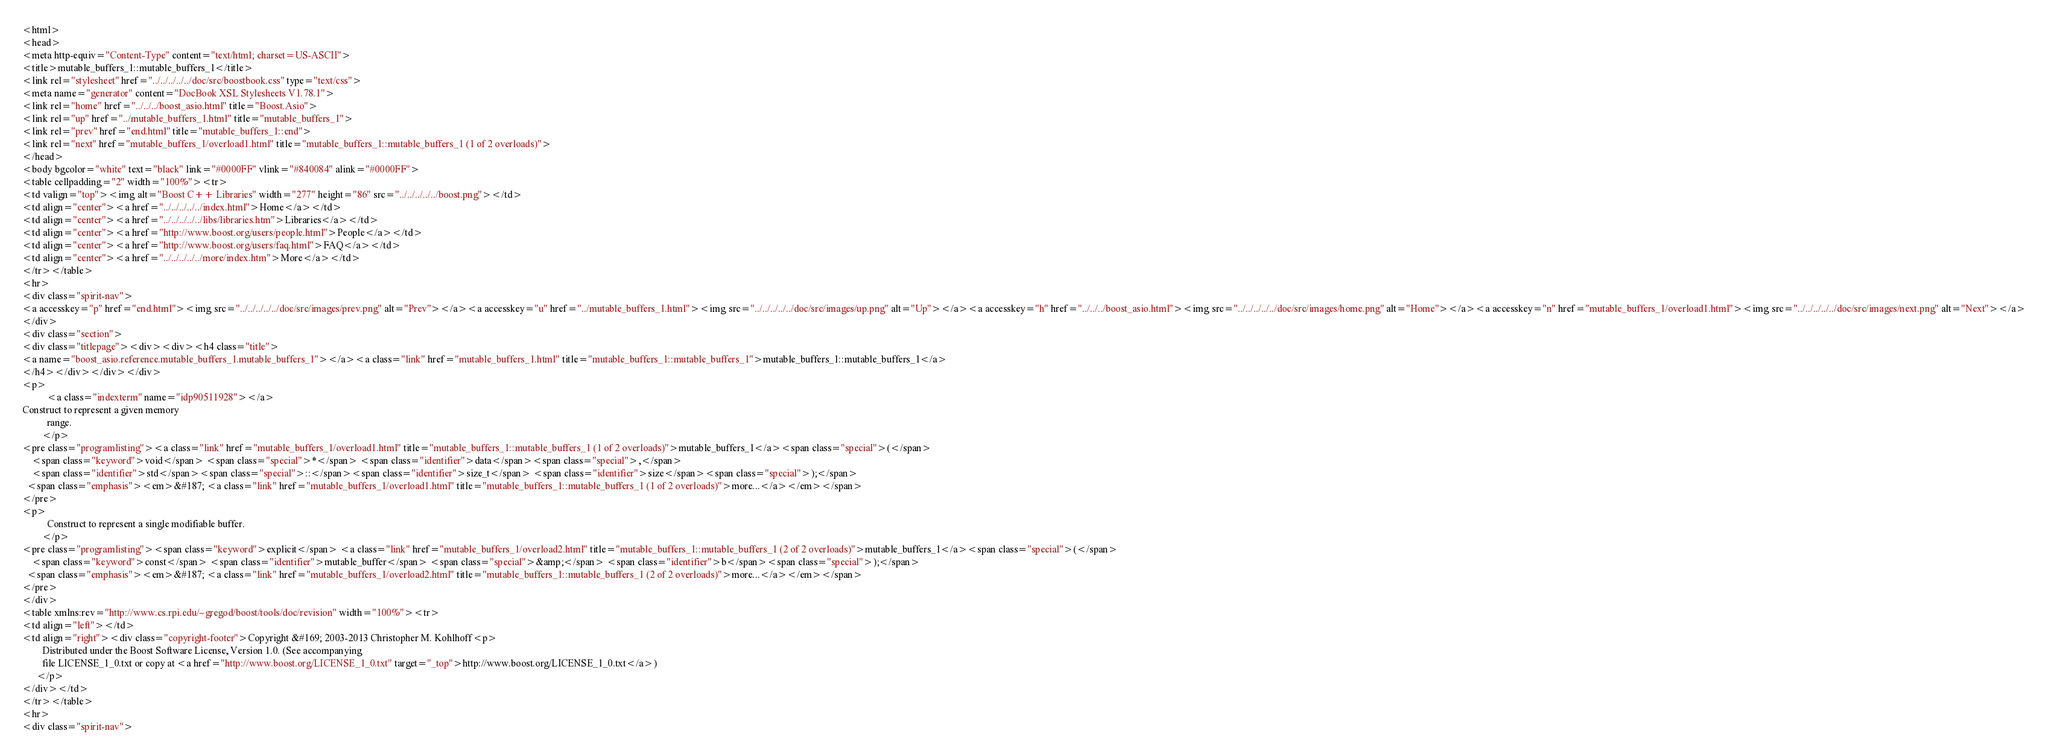<code> <loc_0><loc_0><loc_500><loc_500><_HTML_><html>
<head>
<meta http-equiv="Content-Type" content="text/html; charset=US-ASCII">
<title>mutable_buffers_1::mutable_buffers_1</title>
<link rel="stylesheet" href="../../../../../doc/src/boostbook.css" type="text/css">
<meta name="generator" content="DocBook XSL Stylesheets V1.78.1">
<link rel="home" href="../../../boost_asio.html" title="Boost.Asio">
<link rel="up" href="../mutable_buffers_1.html" title="mutable_buffers_1">
<link rel="prev" href="end.html" title="mutable_buffers_1::end">
<link rel="next" href="mutable_buffers_1/overload1.html" title="mutable_buffers_1::mutable_buffers_1 (1 of 2 overloads)">
</head>
<body bgcolor="white" text="black" link="#0000FF" vlink="#840084" alink="#0000FF">
<table cellpadding="2" width="100%"><tr>
<td valign="top"><img alt="Boost C++ Libraries" width="277" height="86" src="../../../../../boost.png"></td>
<td align="center"><a href="../../../../../index.html">Home</a></td>
<td align="center"><a href="../../../../../libs/libraries.htm">Libraries</a></td>
<td align="center"><a href="http://www.boost.org/users/people.html">People</a></td>
<td align="center"><a href="http://www.boost.org/users/faq.html">FAQ</a></td>
<td align="center"><a href="../../../../../more/index.htm">More</a></td>
</tr></table>
<hr>
<div class="spirit-nav">
<a accesskey="p" href="end.html"><img src="../../../../../doc/src/images/prev.png" alt="Prev"></a><a accesskey="u" href="../mutable_buffers_1.html"><img src="../../../../../doc/src/images/up.png" alt="Up"></a><a accesskey="h" href="../../../boost_asio.html"><img src="../../../../../doc/src/images/home.png" alt="Home"></a><a accesskey="n" href="mutable_buffers_1/overload1.html"><img src="../../../../../doc/src/images/next.png" alt="Next"></a>
</div>
<div class="section">
<div class="titlepage"><div><div><h4 class="title">
<a name="boost_asio.reference.mutable_buffers_1.mutable_buffers_1"></a><a class="link" href="mutable_buffers_1.html" title="mutable_buffers_1::mutable_buffers_1">mutable_buffers_1::mutable_buffers_1</a>
</h4></div></div></div>
<p>
          <a class="indexterm" name="idp90511928"></a> 
Construct to represent a given memory
          range.
        </p>
<pre class="programlisting"><a class="link" href="mutable_buffers_1/overload1.html" title="mutable_buffers_1::mutable_buffers_1 (1 of 2 overloads)">mutable_buffers_1</a><span class="special">(</span>
    <span class="keyword">void</span> <span class="special">*</span> <span class="identifier">data</span><span class="special">,</span>
    <span class="identifier">std</span><span class="special">::</span><span class="identifier">size_t</span> <span class="identifier">size</span><span class="special">);</span>
  <span class="emphasis"><em>&#187; <a class="link" href="mutable_buffers_1/overload1.html" title="mutable_buffers_1::mutable_buffers_1 (1 of 2 overloads)">more...</a></em></span>
</pre>
<p>
          Construct to represent a single modifiable buffer.
        </p>
<pre class="programlisting"><span class="keyword">explicit</span> <a class="link" href="mutable_buffers_1/overload2.html" title="mutable_buffers_1::mutable_buffers_1 (2 of 2 overloads)">mutable_buffers_1</a><span class="special">(</span>
    <span class="keyword">const</span> <span class="identifier">mutable_buffer</span> <span class="special">&amp;</span> <span class="identifier">b</span><span class="special">);</span>
  <span class="emphasis"><em>&#187; <a class="link" href="mutable_buffers_1/overload2.html" title="mutable_buffers_1::mutable_buffers_1 (2 of 2 overloads)">more...</a></em></span>
</pre>
</div>
<table xmlns:rev="http://www.cs.rpi.edu/~gregod/boost/tools/doc/revision" width="100%"><tr>
<td align="left"></td>
<td align="right"><div class="copyright-footer">Copyright &#169; 2003-2013 Christopher M. Kohlhoff<p>
        Distributed under the Boost Software License, Version 1.0. (See accompanying
        file LICENSE_1_0.txt or copy at <a href="http://www.boost.org/LICENSE_1_0.txt" target="_top">http://www.boost.org/LICENSE_1_0.txt</a>)
      </p>
</div></td>
</tr></table>
<hr>
<div class="spirit-nav"></code> 